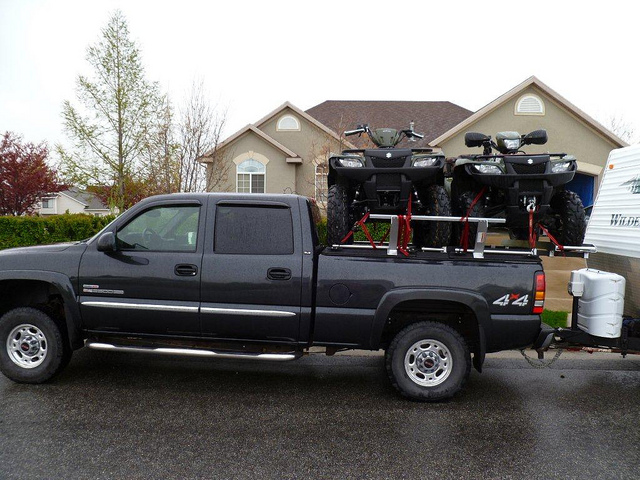<image>What hometown event might this truck have been in? There is no way to know what hometown event this truck might have been in. It could potentially be in a parade, a race, or even a camping event. What kind of event is this? It is ambiguous what kind of event this is. It could be a race, a sporting event, or camping. What hometown event might this truck have been in? It is unknown what hometown event this truck might have been in. What kind of event is this? It is ambiguous what kind of event this is. It can be seen as a race, a sporting event, or a camping trip. 